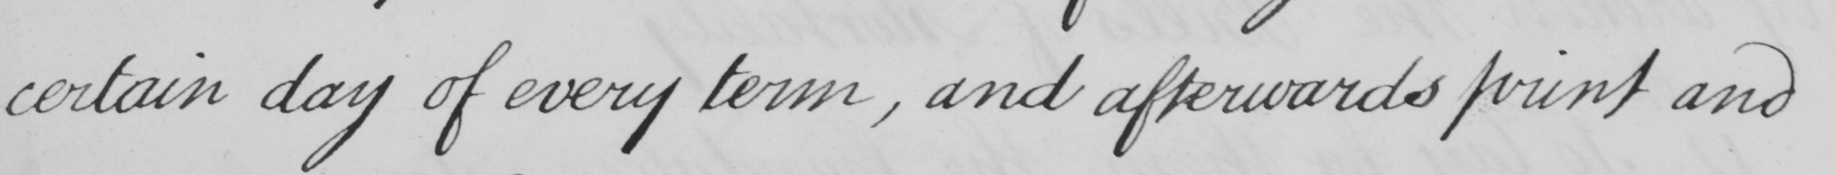Please provide the text content of this handwritten line. certain day of every term , and afterwards print and 